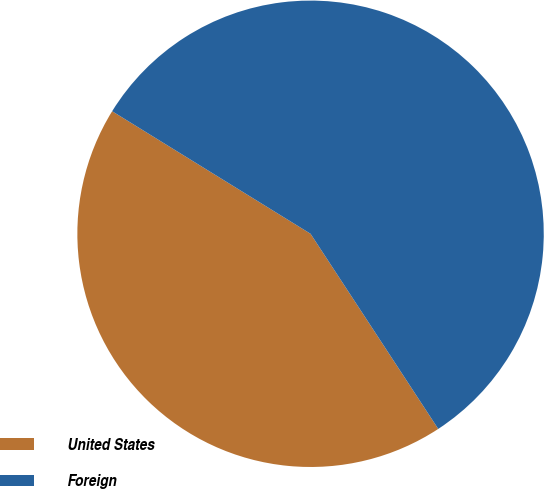Convert chart to OTSL. <chart><loc_0><loc_0><loc_500><loc_500><pie_chart><fcel>United States<fcel>Foreign<nl><fcel>43.03%<fcel>56.97%<nl></chart> 